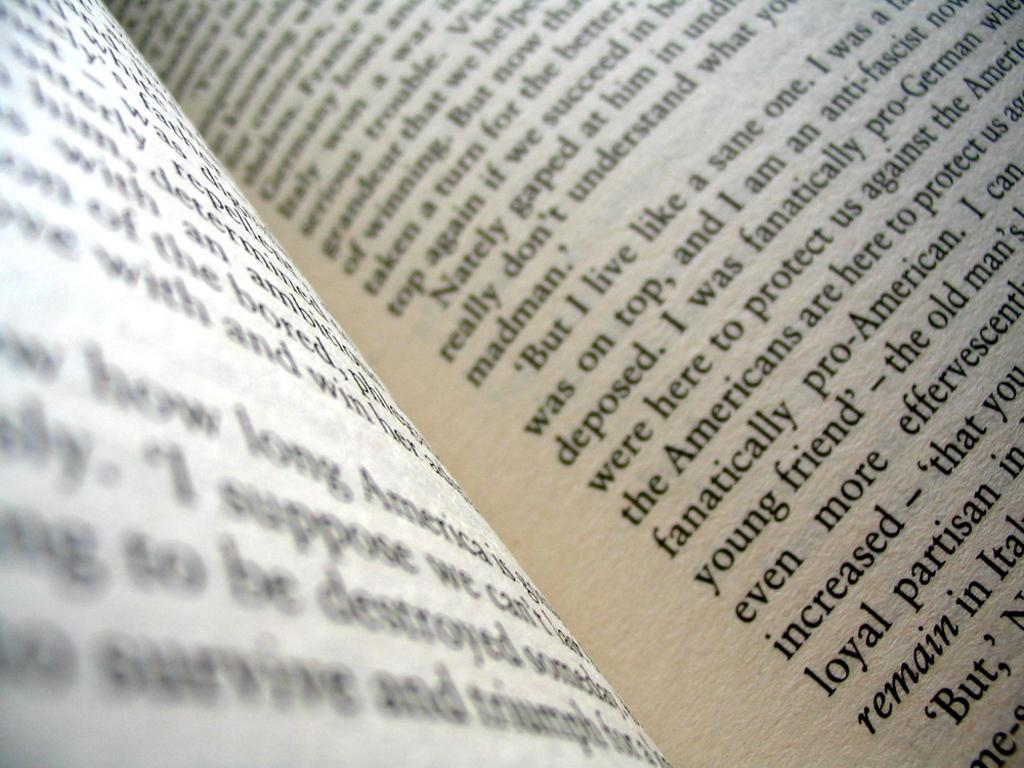Provide a one-sentence caption for the provided image. Chapter book that expresses about being Pro German against the Americans. 